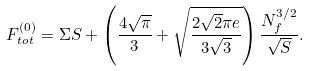<formula> <loc_0><loc_0><loc_500><loc_500>F _ { t o t } ^ { ( 0 ) } = \Sigma S + \left ( \frac { 4 \sqrt { \pi } } { 3 } + \sqrt { \frac { 2 \sqrt { 2 } \pi e } { 3 \sqrt { 3 } } } \right ) \frac { N _ { f } ^ { 3 / 2 } } { \sqrt { S } } .</formula> 